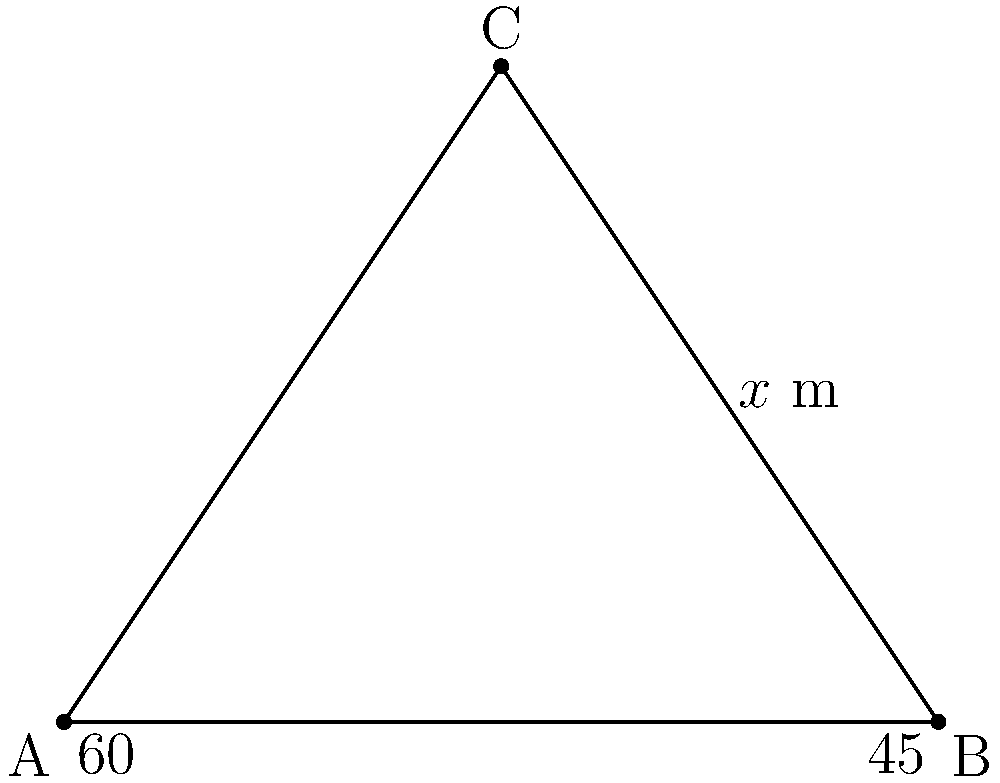In a crucial moment during a football match, player A is positioned at one corner of the field, player B is at the opposite corner, and player C is at the midpoint of the sideline. The angle between players A and C, as seen from B, is 45°, while the angle between players B and C, as seen from A, is 60°. If the distance between players B and C is $x$ meters, what is the distance between players A and B? Let's approach this step-by-step using the law of sines:

1) First, let's identify what we know:
   - Angle BAC = 60°
   - Angle ABC = 45°
   - The third angle, BCA, can be calculated: 180° - 60° - 45° = 75°
   - The distance BC is $x$ meters

2) The law of sines states that:
   $$\frac{a}{\sin A} = \frac{b}{\sin B} = \frac{c}{\sin C}$$
   where a, b, and c are the lengths of the sides opposite to angles A, B, and C respectively.

3) We want to find AB, which is opposite to the 75° angle. Let's call this length $y$. We can set up the following equation:
   $$\frac{y}{\sin 75°} = \frac{x}{\sin 60°}$$

4) Rearranging this equation:
   $$y = \frac{x \sin 75°}{\sin 60°}$$

5) We know that $\sin 60° = \frac{\sqrt{3}}{2}$ and $\sin 75° = \frac{\sqrt{6} + \sqrt{2}}{4}$

6) Substituting these values:
   $$y = \frac{x (\frac{\sqrt{6} + \sqrt{2}}{4})}{\frac{\sqrt{3}}{2}}$$

7) Simplifying:
   $$y = \frac{x (\sqrt{6} + \sqrt{2})}{2\sqrt{3}}$$

8) This can be further simplified to:
   $$y = \frac{x (\sqrt{2} + 1)}{\sqrt{3}}$$

This is our final expression for the distance between players A and B in terms of $x$.
Answer: $\frac{x (\sqrt{2} + 1)}{\sqrt{3}}$ meters 